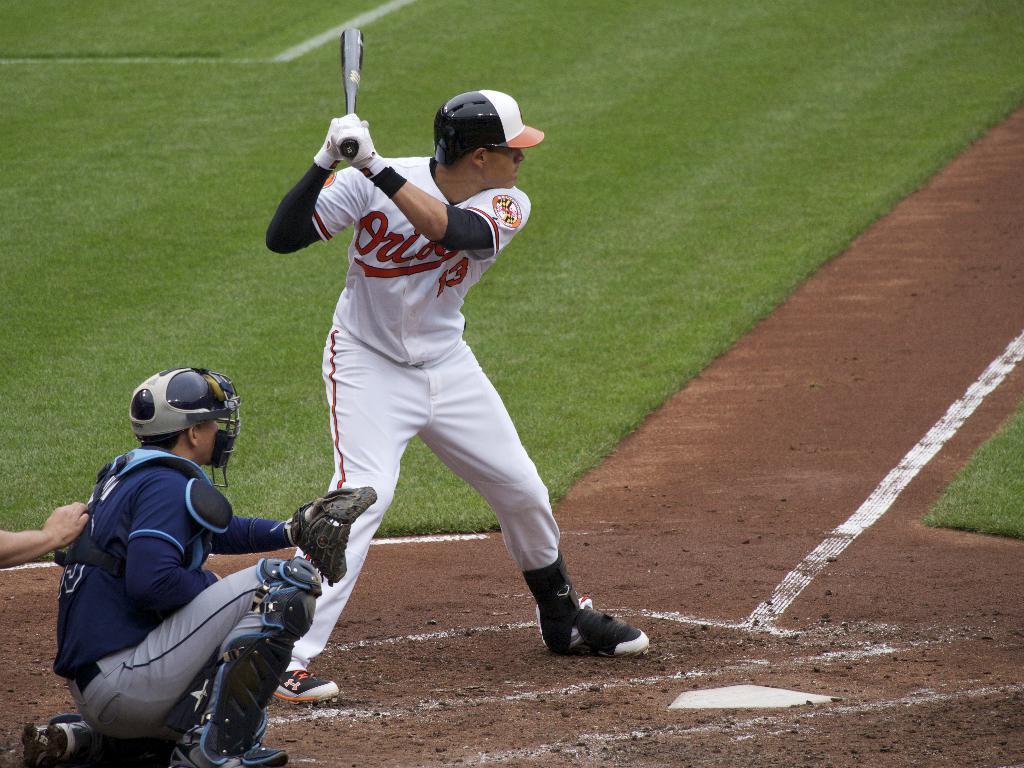In one or two sentences, can you explain what this image depicts? In this image there are two persons. The man in the center is holding baseball bat in his hand. The man to the left is kneeling on the ground. He is wearing catcher gloves and a helmet. There are markings on the ground. Behind them there's grass on the ground. 